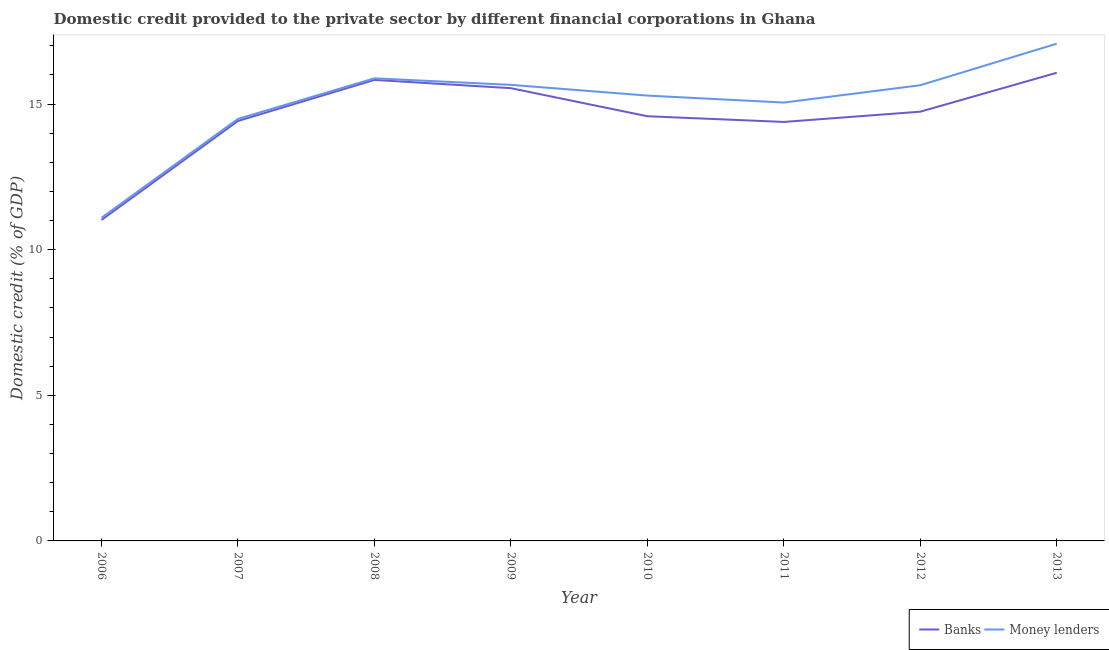How many different coloured lines are there?
Offer a very short reply. 2. Is the number of lines equal to the number of legend labels?
Provide a short and direct response. Yes. What is the domestic credit provided by banks in 2012?
Ensure brevity in your answer.  14.74. Across all years, what is the maximum domestic credit provided by banks?
Offer a very short reply. 16.07. Across all years, what is the minimum domestic credit provided by money lenders?
Offer a very short reply. 11.09. In which year was the domestic credit provided by money lenders minimum?
Your response must be concise. 2006. What is the total domestic credit provided by banks in the graph?
Your response must be concise. 116.58. What is the difference between the domestic credit provided by banks in 2009 and that in 2011?
Give a very brief answer. 1.16. What is the difference between the domestic credit provided by banks in 2009 and the domestic credit provided by money lenders in 2006?
Offer a very short reply. 4.45. What is the average domestic credit provided by money lenders per year?
Keep it short and to the point. 15.02. In the year 2008, what is the difference between the domestic credit provided by money lenders and domestic credit provided by banks?
Provide a short and direct response. 0.05. In how many years, is the domestic credit provided by banks greater than 7 %?
Your answer should be compact. 8. What is the ratio of the domestic credit provided by money lenders in 2008 to that in 2012?
Ensure brevity in your answer.  1.02. Is the domestic credit provided by banks in 2008 less than that in 2010?
Provide a short and direct response. No. Is the difference between the domestic credit provided by banks in 2011 and 2012 greater than the difference between the domestic credit provided by money lenders in 2011 and 2012?
Provide a succinct answer. Yes. What is the difference between the highest and the second highest domestic credit provided by money lenders?
Your answer should be compact. 1.19. What is the difference between the highest and the lowest domestic credit provided by money lenders?
Provide a short and direct response. 5.98. Does the domestic credit provided by banks monotonically increase over the years?
Make the answer very short. No. How many lines are there?
Your answer should be compact. 2. How many years are there in the graph?
Provide a short and direct response. 8. What is the difference between two consecutive major ticks on the Y-axis?
Keep it short and to the point. 5. Are the values on the major ticks of Y-axis written in scientific E-notation?
Make the answer very short. No. Does the graph contain grids?
Give a very brief answer. No. Where does the legend appear in the graph?
Make the answer very short. Bottom right. How many legend labels are there?
Offer a terse response. 2. How are the legend labels stacked?
Your answer should be very brief. Horizontal. What is the title of the graph?
Your answer should be very brief. Domestic credit provided to the private sector by different financial corporations in Ghana. What is the label or title of the Y-axis?
Your response must be concise. Domestic credit (% of GDP). What is the Domestic credit (% of GDP) of Banks in 2006?
Make the answer very short. 11.02. What is the Domestic credit (% of GDP) of Money lenders in 2006?
Your answer should be compact. 11.09. What is the Domestic credit (% of GDP) of Banks in 2007?
Your answer should be very brief. 14.42. What is the Domestic credit (% of GDP) in Money lenders in 2007?
Your answer should be very brief. 14.49. What is the Domestic credit (% of GDP) in Banks in 2008?
Your response must be concise. 15.83. What is the Domestic credit (% of GDP) in Money lenders in 2008?
Make the answer very short. 15.88. What is the Domestic credit (% of GDP) in Banks in 2009?
Keep it short and to the point. 15.54. What is the Domestic credit (% of GDP) in Money lenders in 2009?
Keep it short and to the point. 15.66. What is the Domestic credit (% of GDP) of Banks in 2010?
Keep it short and to the point. 14.58. What is the Domestic credit (% of GDP) in Money lenders in 2010?
Keep it short and to the point. 15.29. What is the Domestic credit (% of GDP) in Banks in 2011?
Give a very brief answer. 14.38. What is the Domestic credit (% of GDP) in Money lenders in 2011?
Offer a terse response. 15.05. What is the Domestic credit (% of GDP) of Banks in 2012?
Your response must be concise. 14.74. What is the Domestic credit (% of GDP) of Money lenders in 2012?
Provide a succinct answer. 15.64. What is the Domestic credit (% of GDP) of Banks in 2013?
Offer a terse response. 16.07. What is the Domestic credit (% of GDP) in Money lenders in 2013?
Offer a terse response. 17.07. Across all years, what is the maximum Domestic credit (% of GDP) of Banks?
Give a very brief answer. 16.07. Across all years, what is the maximum Domestic credit (% of GDP) in Money lenders?
Ensure brevity in your answer.  17.07. Across all years, what is the minimum Domestic credit (% of GDP) of Banks?
Your answer should be compact. 11.02. Across all years, what is the minimum Domestic credit (% of GDP) in Money lenders?
Your answer should be compact. 11.09. What is the total Domestic credit (% of GDP) of Banks in the graph?
Provide a succinct answer. 116.58. What is the total Domestic credit (% of GDP) in Money lenders in the graph?
Your answer should be very brief. 120.18. What is the difference between the Domestic credit (% of GDP) in Banks in 2006 and that in 2007?
Ensure brevity in your answer.  -3.4. What is the difference between the Domestic credit (% of GDP) of Money lenders in 2006 and that in 2007?
Make the answer very short. -3.39. What is the difference between the Domestic credit (% of GDP) of Banks in 2006 and that in 2008?
Provide a short and direct response. -4.81. What is the difference between the Domestic credit (% of GDP) of Money lenders in 2006 and that in 2008?
Your answer should be compact. -4.79. What is the difference between the Domestic credit (% of GDP) of Banks in 2006 and that in 2009?
Provide a succinct answer. -4.52. What is the difference between the Domestic credit (% of GDP) in Money lenders in 2006 and that in 2009?
Your answer should be very brief. -4.56. What is the difference between the Domestic credit (% of GDP) of Banks in 2006 and that in 2010?
Keep it short and to the point. -3.56. What is the difference between the Domestic credit (% of GDP) of Money lenders in 2006 and that in 2010?
Keep it short and to the point. -4.2. What is the difference between the Domestic credit (% of GDP) in Banks in 2006 and that in 2011?
Offer a very short reply. -3.37. What is the difference between the Domestic credit (% of GDP) in Money lenders in 2006 and that in 2011?
Offer a terse response. -3.96. What is the difference between the Domestic credit (% of GDP) of Banks in 2006 and that in 2012?
Provide a succinct answer. -3.72. What is the difference between the Domestic credit (% of GDP) of Money lenders in 2006 and that in 2012?
Offer a terse response. -4.55. What is the difference between the Domestic credit (% of GDP) of Banks in 2006 and that in 2013?
Offer a terse response. -5.05. What is the difference between the Domestic credit (% of GDP) of Money lenders in 2006 and that in 2013?
Make the answer very short. -5.98. What is the difference between the Domestic credit (% of GDP) of Banks in 2007 and that in 2008?
Keep it short and to the point. -1.41. What is the difference between the Domestic credit (% of GDP) in Money lenders in 2007 and that in 2008?
Your answer should be very brief. -1.39. What is the difference between the Domestic credit (% of GDP) in Banks in 2007 and that in 2009?
Your answer should be very brief. -1.13. What is the difference between the Domestic credit (% of GDP) of Money lenders in 2007 and that in 2009?
Offer a terse response. -1.17. What is the difference between the Domestic credit (% of GDP) in Banks in 2007 and that in 2010?
Provide a succinct answer. -0.16. What is the difference between the Domestic credit (% of GDP) of Money lenders in 2007 and that in 2010?
Provide a short and direct response. -0.8. What is the difference between the Domestic credit (% of GDP) in Banks in 2007 and that in 2011?
Ensure brevity in your answer.  0.03. What is the difference between the Domestic credit (% of GDP) of Money lenders in 2007 and that in 2011?
Keep it short and to the point. -0.56. What is the difference between the Domestic credit (% of GDP) of Banks in 2007 and that in 2012?
Offer a terse response. -0.32. What is the difference between the Domestic credit (% of GDP) in Money lenders in 2007 and that in 2012?
Your answer should be compact. -1.16. What is the difference between the Domestic credit (% of GDP) in Banks in 2007 and that in 2013?
Your answer should be very brief. -1.66. What is the difference between the Domestic credit (% of GDP) in Money lenders in 2007 and that in 2013?
Give a very brief answer. -2.58. What is the difference between the Domestic credit (% of GDP) in Banks in 2008 and that in 2009?
Ensure brevity in your answer.  0.28. What is the difference between the Domestic credit (% of GDP) in Money lenders in 2008 and that in 2009?
Your response must be concise. 0.22. What is the difference between the Domestic credit (% of GDP) in Banks in 2008 and that in 2010?
Ensure brevity in your answer.  1.25. What is the difference between the Domestic credit (% of GDP) of Money lenders in 2008 and that in 2010?
Ensure brevity in your answer.  0.59. What is the difference between the Domestic credit (% of GDP) of Banks in 2008 and that in 2011?
Make the answer very short. 1.44. What is the difference between the Domestic credit (% of GDP) of Money lenders in 2008 and that in 2011?
Your answer should be compact. 0.83. What is the difference between the Domestic credit (% of GDP) in Banks in 2008 and that in 2012?
Your answer should be very brief. 1.09. What is the difference between the Domestic credit (% of GDP) in Money lenders in 2008 and that in 2012?
Ensure brevity in your answer.  0.24. What is the difference between the Domestic credit (% of GDP) of Banks in 2008 and that in 2013?
Ensure brevity in your answer.  -0.25. What is the difference between the Domestic credit (% of GDP) in Money lenders in 2008 and that in 2013?
Make the answer very short. -1.19. What is the difference between the Domestic credit (% of GDP) in Banks in 2009 and that in 2010?
Your response must be concise. 0.96. What is the difference between the Domestic credit (% of GDP) of Money lenders in 2009 and that in 2010?
Ensure brevity in your answer.  0.37. What is the difference between the Domestic credit (% of GDP) in Banks in 2009 and that in 2011?
Ensure brevity in your answer.  1.16. What is the difference between the Domestic credit (% of GDP) in Money lenders in 2009 and that in 2011?
Keep it short and to the point. 0.61. What is the difference between the Domestic credit (% of GDP) in Banks in 2009 and that in 2012?
Your answer should be compact. 0.81. What is the difference between the Domestic credit (% of GDP) of Money lenders in 2009 and that in 2012?
Provide a succinct answer. 0.01. What is the difference between the Domestic credit (% of GDP) of Banks in 2009 and that in 2013?
Offer a terse response. -0.53. What is the difference between the Domestic credit (% of GDP) in Money lenders in 2009 and that in 2013?
Provide a short and direct response. -1.41. What is the difference between the Domestic credit (% of GDP) in Banks in 2010 and that in 2011?
Provide a short and direct response. 0.2. What is the difference between the Domestic credit (% of GDP) of Money lenders in 2010 and that in 2011?
Your answer should be compact. 0.24. What is the difference between the Domestic credit (% of GDP) of Banks in 2010 and that in 2012?
Offer a terse response. -0.16. What is the difference between the Domestic credit (% of GDP) of Money lenders in 2010 and that in 2012?
Provide a short and direct response. -0.36. What is the difference between the Domestic credit (% of GDP) of Banks in 2010 and that in 2013?
Your answer should be very brief. -1.49. What is the difference between the Domestic credit (% of GDP) in Money lenders in 2010 and that in 2013?
Provide a short and direct response. -1.78. What is the difference between the Domestic credit (% of GDP) in Banks in 2011 and that in 2012?
Provide a short and direct response. -0.35. What is the difference between the Domestic credit (% of GDP) in Money lenders in 2011 and that in 2012?
Provide a succinct answer. -0.59. What is the difference between the Domestic credit (% of GDP) of Banks in 2011 and that in 2013?
Provide a succinct answer. -1.69. What is the difference between the Domestic credit (% of GDP) in Money lenders in 2011 and that in 2013?
Give a very brief answer. -2.02. What is the difference between the Domestic credit (% of GDP) in Banks in 2012 and that in 2013?
Ensure brevity in your answer.  -1.34. What is the difference between the Domestic credit (% of GDP) in Money lenders in 2012 and that in 2013?
Your answer should be compact. -1.43. What is the difference between the Domestic credit (% of GDP) in Banks in 2006 and the Domestic credit (% of GDP) in Money lenders in 2007?
Offer a very short reply. -3.47. What is the difference between the Domestic credit (% of GDP) of Banks in 2006 and the Domestic credit (% of GDP) of Money lenders in 2008?
Make the answer very short. -4.86. What is the difference between the Domestic credit (% of GDP) of Banks in 2006 and the Domestic credit (% of GDP) of Money lenders in 2009?
Offer a very short reply. -4.64. What is the difference between the Domestic credit (% of GDP) in Banks in 2006 and the Domestic credit (% of GDP) in Money lenders in 2010?
Provide a succinct answer. -4.27. What is the difference between the Domestic credit (% of GDP) in Banks in 2006 and the Domestic credit (% of GDP) in Money lenders in 2011?
Ensure brevity in your answer.  -4.03. What is the difference between the Domestic credit (% of GDP) of Banks in 2006 and the Domestic credit (% of GDP) of Money lenders in 2012?
Your response must be concise. -4.63. What is the difference between the Domestic credit (% of GDP) of Banks in 2006 and the Domestic credit (% of GDP) of Money lenders in 2013?
Keep it short and to the point. -6.05. What is the difference between the Domestic credit (% of GDP) of Banks in 2007 and the Domestic credit (% of GDP) of Money lenders in 2008?
Offer a very short reply. -1.46. What is the difference between the Domestic credit (% of GDP) of Banks in 2007 and the Domestic credit (% of GDP) of Money lenders in 2009?
Offer a terse response. -1.24. What is the difference between the Domestic credit (% of GDP) of Banks in 2007 and the Domestic credit (% of GDP) of Money lenders in 2010?
Provide a succinct answer. -0.87. What is the difference between the Domestic credit (% of GDP) in Banks in 2007 and the Domestic credit (% of GDP) in Money lenders in 2011?
Provide a succinct answer. -0.63. What is the difference between the Domestic credit (% of GDP) of Banks in 2007 and the Domestic credit (% of GDP) of Money lenders in 2012?
Your response must be concise. -1.23. What is the difference between the Domestic credit (% of GDP) in Banks in 2007 and the Domestic credit (% of GDP) in Money lenders in 2013?
Your answer should be very brief. -2.65. What is the difference between the Domestic credit (% of GDP) in Banks in 2008 and the Domestic credit (% of GDP) in Money lenders in 2009?
Your answer should be compact. 0.17. What is the difference between the Domestic credit (% of GDP) of Banks in 2008 and the Domestic credit (% of GDP) of Money lenders in 2010?
Your answer should be very brief. 0.54. What is the difference between the Domestic credit (% of GDP) of Banks in 2008 and the Domestic credit (% of GDP) of Money lenders in 2011?
Give a very brief answer. 0.78. What is the difference between the Domestic credit (% of GDP) in Banks in 2008 and the Domestic credit (% of GDP) in Money lenders in 2012?
Provide a short and direct response. 0.18. What is the difference between the Domestic credit (% of GDP) in Banks in 2008 and the Domestic credit (% of GDP) in Money lenders in 2013?
Offer a terse response. -1.24. What is the difference between the Domestic credit (% of GDP) of Banks in 2009 and the Domestic credit (% of GDP) of Money lenders in 2010?
Keep it short and to the point. 0.25. What is the difference between the Domestic credit (% of GDP) in Banks in 2009 and the Domestic credit (% of GDP) in Money lenders in 2011?
Provide a short and direct response. 0.49. What is the difference between the Domestic credit (% of GDP) in Banks in 2009 and the Domestic credit (% of GDP) in Money lenders in 2012?
Give a very brief answer. -0.1. What is the difference between the Domestic credit (% of GDP) in Banks in 2009 and the Domestic credit (% of GDP) in Money lenders in 2013?
Make the answer very short. -1.53. What is the difference between the Domestic credit (% of GDP) of Banks in 2010 and the Domestic credit (% of GDP) of Money lenders in 2011?
Offer a very short reply. -0.47. What is the difference between the Domestic credit (% of GDP) of Banks in 2010 and the Domestic credit (% of GDP) of Money lenders in 2012?
Provide a succinct answer. -1.06. What is the difference between the Domestic credit (% of GDP) in Banks in 2010 and the Domestic credit (% of GDP) in Money lenders in 2013?
Give a very brief answer. -2.49. What is the difference between the Domestic credit (% of GDP) of Banks in 2011 and the Domestic credit (% of GDP) of Money lenders in 2012?
Offer a very short reply. -1.26. What is the difference between the Domestic credit (% of GDP) in Banks in 2011 and the Domestic credit (% of GDP) in Money lenders in 2013?
Make the answer very short. -2.69. What is the difference between the Domestic credit (% of GDP) in Banks in 2012 and the Domestic credit (% of GDP) in Money lenders in 2013?
Your answer should be compact. -2.33. What is the average Domestic credit (% of GDP) in Banks per year?
Make the answer very short. 14.57. What is the average Domestic credit (% of GDP) of Money lenders per year?
Keep it short and to the point. 15.02. In the year 2006, what is the difference between the Domestic credit (% of GDP) of Banks and Domestic credit (% of GDP) of Money lenders?
Keep it short and to the point. -0.07. In the year 2007, what is the difference between the Domestic credit (% of GDP) in Banks and Domestic credit (% of GDP) in Money lenders?
Your response must be concise. -0.07. In the year 2008, what is the difference between the Domestic credit (% of GDP) in Banks and Domestic credit (% of GDP) in Money lenders?
Provide a short and direct response. -0.05. In the year 2009, what is the difference between the Domestic credit (% of GDP) in Banks and Domestic credit (% of GDP) in Money lenders?
Offer a terse response. -0.11. In the year 2010, what is the difference between the Domestic credit (% of GDP) in Banks and Domestic credit (% of GDP) in Money lenders?
Your answer should be compact. -0.71. In the year 2011, what is the difference between the Domestic credit (% of GDP) of Banks and Domestic credit (% of GDP) of Money lenders?
Ensure brevity in your answer.  -0.67. In the year 2012, what is the difference between the Domestic credit (% of GDP) in Banks and Domestic credit (% of GDP) in Money lenders?
Ensure brevity in your answer.  -0.91. In the year 2013, what is the difference between the Domestic credit (% of GDP) of Banks and Domestic credit (% of GDP) of Money lenders?
Keep it short and to the point. -1. What is the ratio of the Domestic credit (% of GDP) of Banks in 2006 to that in 2007?
Your answer should be compact. 0.76. What is the ratio of the Domestic credit (% of GDP) of Money lenders in 2006 to that in 2007?
Offer a very short reply. 0.77. What is the ratio of the Domestic credit (% of GDP) in Banks in 2006 to that in 2008?
Keep it short and to the point. 0.7. What is the ratio of the Domestic credit (% of GDP) in Money lenders in 2006 to that in 2008?
Offer a very short reply. 0.7. What is the ratio of the Domestic credit (% of GDP) of Banks in 2006 to that in 2009?
Give a very brief answer. 0.71. What is the ratio of the Domestic credit (% of GDP) in Money lenders in 2006 to that in 2009?
Provide a succinct answer. 0.71. What is the ratio of the Domestic credit (% of GDP) in Banks in 2006 to that in 2010?
Make the answer very short. 0.76. What is the ratio of the Domestic credit (% of GDP) of Money lenders in 2006 to that in 2010?
Ensure brevity in your answer.  0.73. What is the ratio of the Domestic credit (% of GDP) of Banks in 2006 to that in 2011?
Provide a short and direct response. 0.77. What is the ratio of the Domestic credit (% of GDP) in Money lenders in 2006 to that in 2011?
Provide a short and direct response. 0.74. What is the ratio of the Domestic credit (% of GDP) of Banks in 2006 to that in 2012?
Ensure brevity in your answer.  0.75. What is the ratio of the Domestic credit (% of GDP) of Money lenders in 2006 to that in 2012?
Ensure brevity in your answer.  0.71. What is the ratio of the Domestic credit (% of GDP) in Banks in 2006 to that in 2013?
Your answer should be compact. 0.69. What is the ratio of the Domestic credit (% of GDP) of Money lenders in 2006 to that in 2013?
Offer a terse response. 0.65. What is the ratio of the Domestic credit (% of GDP) of Banks in 2007 to that in 2008?
Ensure brevity in your answer.  0.91. What is the ratio of the Domestic credit (% of GDP) in Money lenders in 2007 to that in 2008?
Offer a very short reply. 0.91. What is the ratio of the Domestic credit (% of GDP) in Banks in 2007 to that in 2009?
Ensure brevity in your answer.  0.93. What is the ratio of the Domestic credit (% of GDP) in Money lenders in 2007 to that in 2009?
Provide a short and direct response. 0.93. What is the ratio of the Domestic credit (% of GDP) in Banks in 2007 to that in 2010?
Your response must be concise. 0.99. What is the ratio of the Domestic credit (% of GDP) in Money lenders in 2007 to that in 2010?
Provide a succinct answer. 0.95. What is the ratio of the Domestic credit (% of GDP) of Money lenders in 2007 to that in 2011?
Give a very brief answer. 0.96. What is the ratio of the Domestic credit (% of GDP) of Banks in 2007 to that in 2012?
Your answer should be compact. 0.98. What is the ratio of the Domestic credit (% of GDP) of Money lenders in 2007 to that in 2012?
Provide a short and direct response. 0.93. What is the ratio of the Domestic credit (% of GDP) of Banks in 2007 to that in 2013?
Offer a very short reply. 0.9. What is the ratio of the Domestic credit (% of GDP) of Money lenders in 2007 to that in 2013?
Provide a short and direct response. 0.85. What is the ratio of the Domestic credit (% of GDP) in Banks in 2008 to that in 2009?
Provide a short and direct response. 1.02. What is the ratio of the Domestic credit (% of GDP) in Money lenders in 2008 to that in 2009?
Provide a short and direct response. 1.01. What is the ratio of the Domestic credit (% of GDP) of Banks in 2008 to that in 2010?
Your answer should be compact. 1.09. What is the ratio of the Domestic credit (% of GDP) in Money lenders in 2008 to that in 2010?
Your answer should be compact. 1.04. What is the ratio of the Domestic credit (% of GDP) in Banks in 2008 to that in 2011?
Provide a succinct answer. 1.1. What is the ratio of the Domestic credit (% of GDP) in Money lenders in 2008 to that in 2011?
Keep it short and to the point. 1.06. What is the ratio of the Domestic credit (% of GDP) of Banks in 2008 to that in 2012?
Provide a short and direct response. 1.07. What is the ratio of the Domestic credit (% of GDP) in Money lenders in 2008 to that in 2012?
Your response must be concise. 1.02. What is the ratio of the Domestic credit (% of GDP) of Banks in 2008 to that in 2013?
Offer a terse response. 0.98. What is the ratio of the Domestic credit (% of GDP) of Money lenders in 2008 to that in 2013?
Keep it short and to the point. 0.93. What is the ratio of the Domestic credit (% of GDP) in Banks in 2009 to that in 2010?
Offer a very short reply. 1.07. What is the ratio of the Domestic credit (% of GDP) in Money lenders in 2009 to that in 2010?
Your response must be concise. 1.02. What is the ratio of the Domestic credit (% of GDP) of Banks in 2009 to that in 2011?
Your answer should be compact. 1.08. What is the ratio of the Domestic credit (% of GDP) of Money lenders in 2009 to that in 2011?
Make the answer very short. 1.04. What is the ratio of the Domestic credit (% of GDP) of Banks in 2009 to that in 2012?
Make the answer very short. 1.05. What is the ratio of the Domestic credit (% of GDP) in Money lenders in 2009 to that in 2012?
Offer a terse response. 1. What is the ratio of the Domestic credit (% of GDP) of Banks in 2009 to that in 2013?
Your answer should be very brief. 0.97. What is the ratio of the Domestic credit (% of GDP) in Money lenders in 2009 to that in 2013?
Offer a terse response. 0.92. What is the ratio of the Domestic credit (% of GDP) in Banks in 2010 to that in 2011?
Offer a very short reply. 1.01. What is the ratio of the Domestic credit (% of GDP) in Money lenders in 2010 to that in 2011?
Your response must be concise. 1.02. What is the ratio of the Domestic credit (% of GDP) in Money lenders in 2010 to that in 2012?
Your answer should be very brief. 0.98. What is the ratio of the Domestic credit (% of GDP) of Banks in 2010 to that in 2013?
Provide a succinct answer. 0.91. What is the ratio of the Domestic credit (% of GDP) of Money lenders in 2010 to that in 2013?
Offer a very short reply. 0.9. What is the ratio of the Domestic credit (% of GDP) in Banks in 2011 to that in 2012?
Give a very brief answer. 0.98. What is the ratio of the Domestic credit (% of GDP) of Money lenders in 2011 to that in 2012?
Ensure brevity in your answer.  0.96. What is the ratio of the Domestic credit (% of GDP) of Banks in 2011 to that in 2013?
Provide a succinct answer. 0.9. What is the ratio of the Domestic credit (% of GDP) of Money lenders in 2011 to that in 2013?
Your response must be concise. 0.88. What is the ratio of the Domestic credit (% of GDP) in Banks in 2012 to that in 2013?
Your response must be concise. 0.92. What is the ratio of the Domestic credit (% of GDP) in Money lenders in 2012 to that in 2013?
Offer a very short reply. 0.92. What is the difference between the highest and the second highest Domestic credit (% of GDP) of Banks?
Ensure brevity in your answer.  0.25. What is the difference between the highest and the second highest Domestic credit (% of GDP) in Money lenders?
Make the answer very short. 1.19. What is the difference between the highest and the lowest Domestic credit (% of GDP) of Banks?
Your response must be concise. 5.05. What is the difference between the highest and the lowest Domestic credit (% of GDP) in Money lenders?
Give a very brief answer. 5.98. 